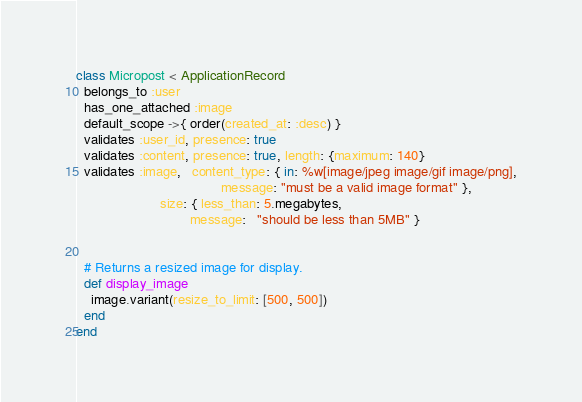<code> <loc_0><loc_0><loc_500><loc_500><_Ruby_>class Micropost < ApplicationRecord
  belongs_to :user
  has_one_attached :image
  default_scope ->{ order(created_at: :desc) }
  validates :user_id, presence: true
  validates :content, presence: true, length: {maximum: 140}
  validates :image,   content_type: { in: %w[image/jpeg image/gif image/png],
                                      message: "must be a valid image format" },
                      size: { less_than: 5.megabytes,
                              message:   "should be less than 5MB" }
                              
                              
  # Returns a resized image for display.
  def display_image
    image.variant(resize_to_limit: [500, 500])
  end
end
</code> 